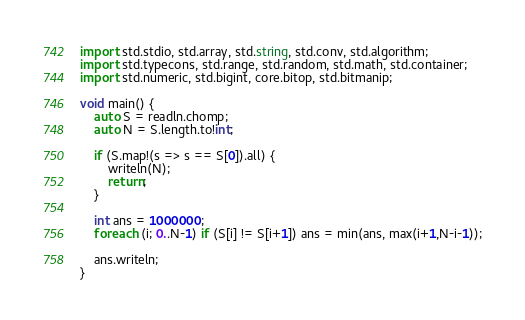Convert code to text. <code><loc_0><loc_0><loc_500><loc_500><_D_>import std.stdio, std.array, std.string, std.conv, std.algorithm;
import std.typecons, std.range, std.random, std.math, std.container;
import std.numeric, std.bigint, core.bitop, std.bitmanip;

void main() {
    auto S = readln.chomp;
    auto N = S.length.to!int;

    if (S.map!(s => s == S[0]).all) {
        writeln(N);
        return;
    }

    int ans = 1000000;
    foreach (i; 0..N-1) if (S[i] != S[i+1]) ans = min(ans, max(i+1,N-i-1));

    ans.writeln;
}
</code> 